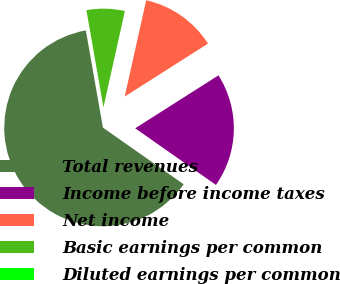Convert chart to OTSL. <chart><loc_0><loc_0><loc_500><loc_500><pie_chart><fcel>Total revenues<fcel>Income before income taxes<fcel>Net income<fcel>Basic earnings per common<fcel>Diluted earnings per common<nl><fcel>62.5%<fcel>18.75%<fcel>12.5%<fcel>6.25%<fcel>0.0%<nl></chart> 